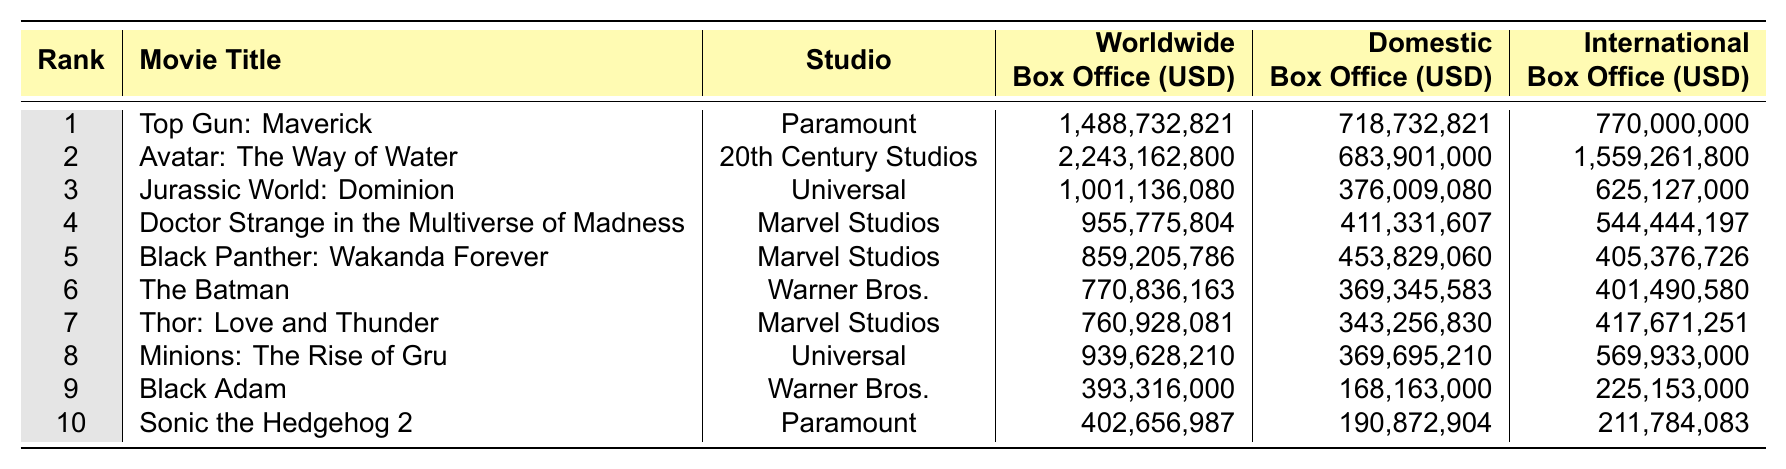What's the highest worldwide box office earning for a movie in 2022? The table lists "Avatar: The Way of Water" as the movie with the highest worldwide box office earnings, totaling 2,243,162,800 USD.
Answer: 2,243,162,800 USD Which movie had the highest domestic box office earnings? Referring to the domestic box office column, "Top Gun: Maverick" had the highest domestic earnings at 718,732,821 USD.
Answer: 718,732,821 USD How much did "Doctor Strange in the Multiverse of Madness" earn internationally? The table shows that "Doctor Strange in the Multiverse of Madness" earned 544,444,197 USD in international box office.
Answer: 544,444,197 USD What is the total worldwide box office earnings of the top three movies? Summing the worldwide earnings of the top three movies: 1,488,732,821 + 2,243,162,800 + 1,001,136,080 = 4,733,031,701 USD.
Answer: 4,733,031,701 USD Is "Black Panther: Wakanda Forever" among the top five movies by worldwide box office earnings? Referring to the rankings, "Black Panther: Wakanda Forever" is ranked 5th, confirming that it's in the top five.
Answer: Yes What is the difference in international earnings between "Jurassic World: Dominion" and "Thor: Love and Thunder"? "Jurassic World: Dominion" earned 625,127,000 USD and "Thor: Love and Thunder" earned 417,671,251 USD. The difference is 625,127,000 - 417,671,251 = 207,455,749 USD.
Answer: 207,455,749 USD Which studio produced the movie with the lowest worldwide box office earnings? "Sonic the Hedgehog 2," produced by Paramount, has the lowest worldwide earnings at 402,656,987 USD.
Answer: Paramount What is the average domestic box office earnings of the Marvel Studios films listed? The domestic earnings for Marvel Studios films are: 411,331,607 (Doctor Strange) + 453,829,060 (Black Panther) + 343,256,830 (Thor) = 1,208,417,497 USD. The average is 1,208,417,497 / 3 = 402,805,832.33 USD, or approximately 402,805,832 USD.
Answer: 402,805,832 USD How many movies had international earnings of more than 500 million USD? "Avatar: The Way of Water," "Jurassic World: Dominion," "Doctor Strange in the Multiverse of Madness," "Minions: The Rise of Gru," and "Top Gun: Maverick" are the movies with international earnings above 500 million USD. That totals to five movies.
Answer: 5 What percentage of the total worldwide earnings did "The Batman" contribute? "The Batman" earned 770,836,163 USD. The total worldwide earnings of all movies is 7,353,297,146 USD. The percentage is (770,836,163 / 7,353,297,146) * 100 ≈ 10.48%.
Answer: Approximately 10.48% 